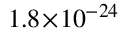Convert formula to latex. <formula><loc_0><loc_0><loc_500><loc_500>1 . 8 \, \times \, 1 0 ^ { - 2 4 }</formula> 